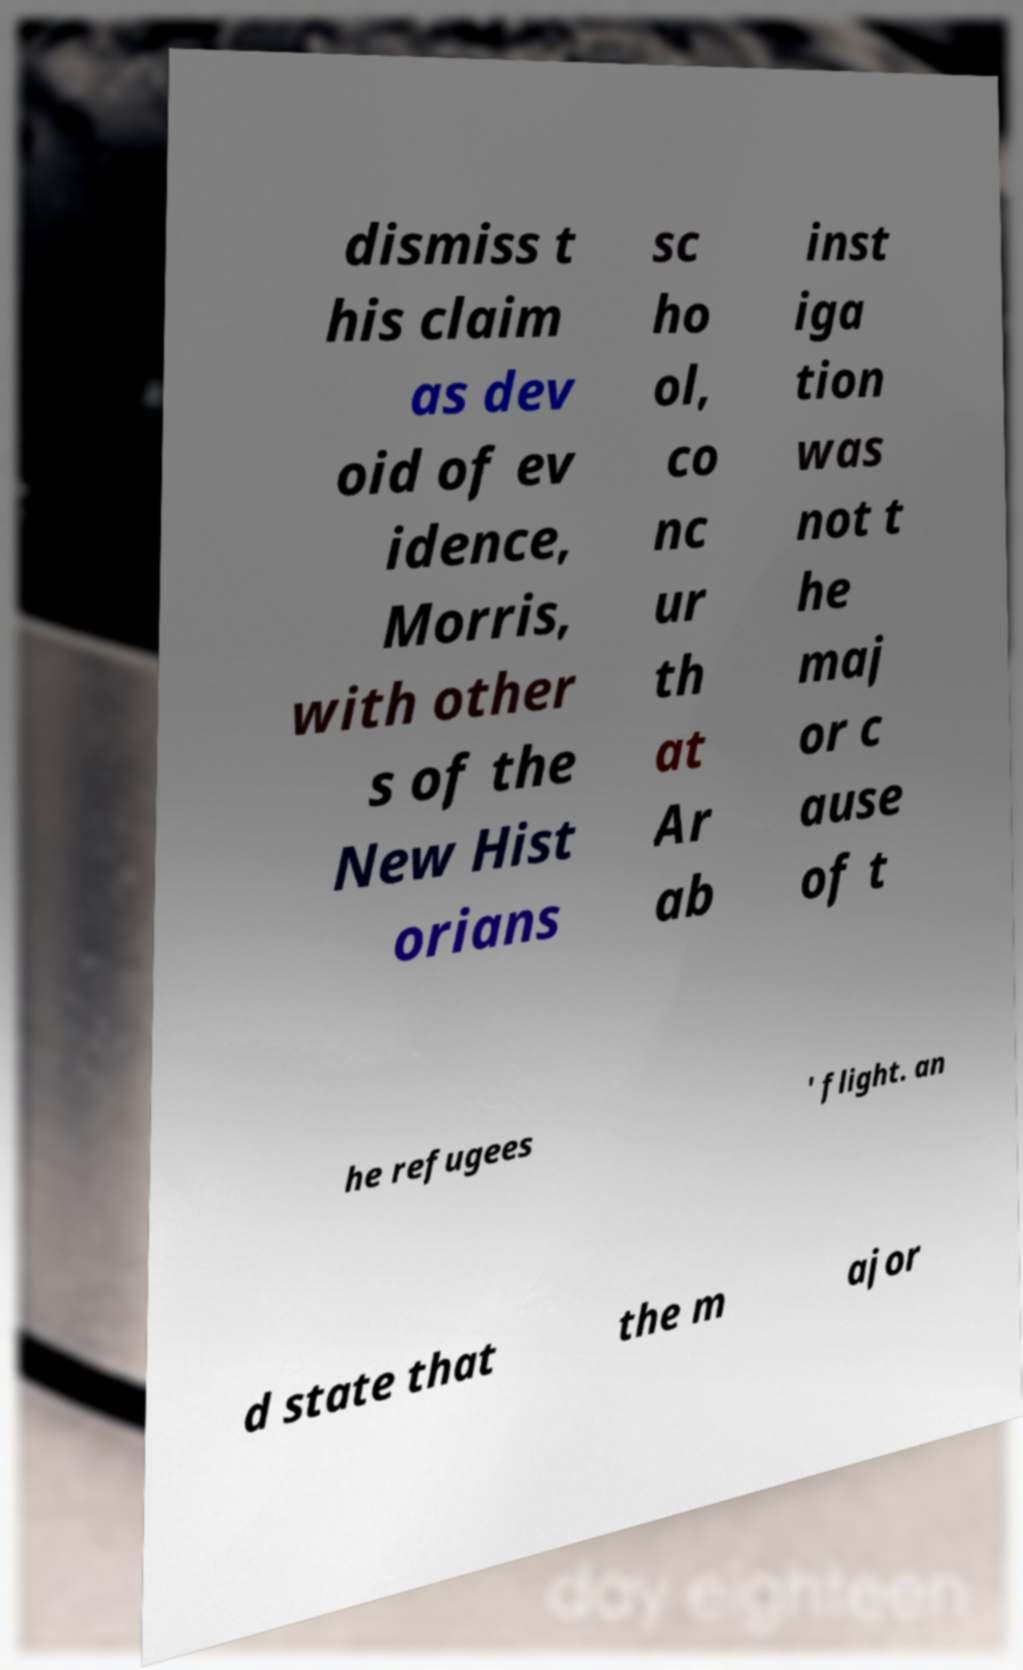There's text embedded in this image that I need extracted. Can you transcribe it verbatim? dismiss t his claim as dev oid of ev idence, Morris, with other s of the New Hist orians sc ho ol, co nc ur th at Ar ab inst iga tion was not t he maj or c ause of t he refugees ' flight. an d state that the m ajor 